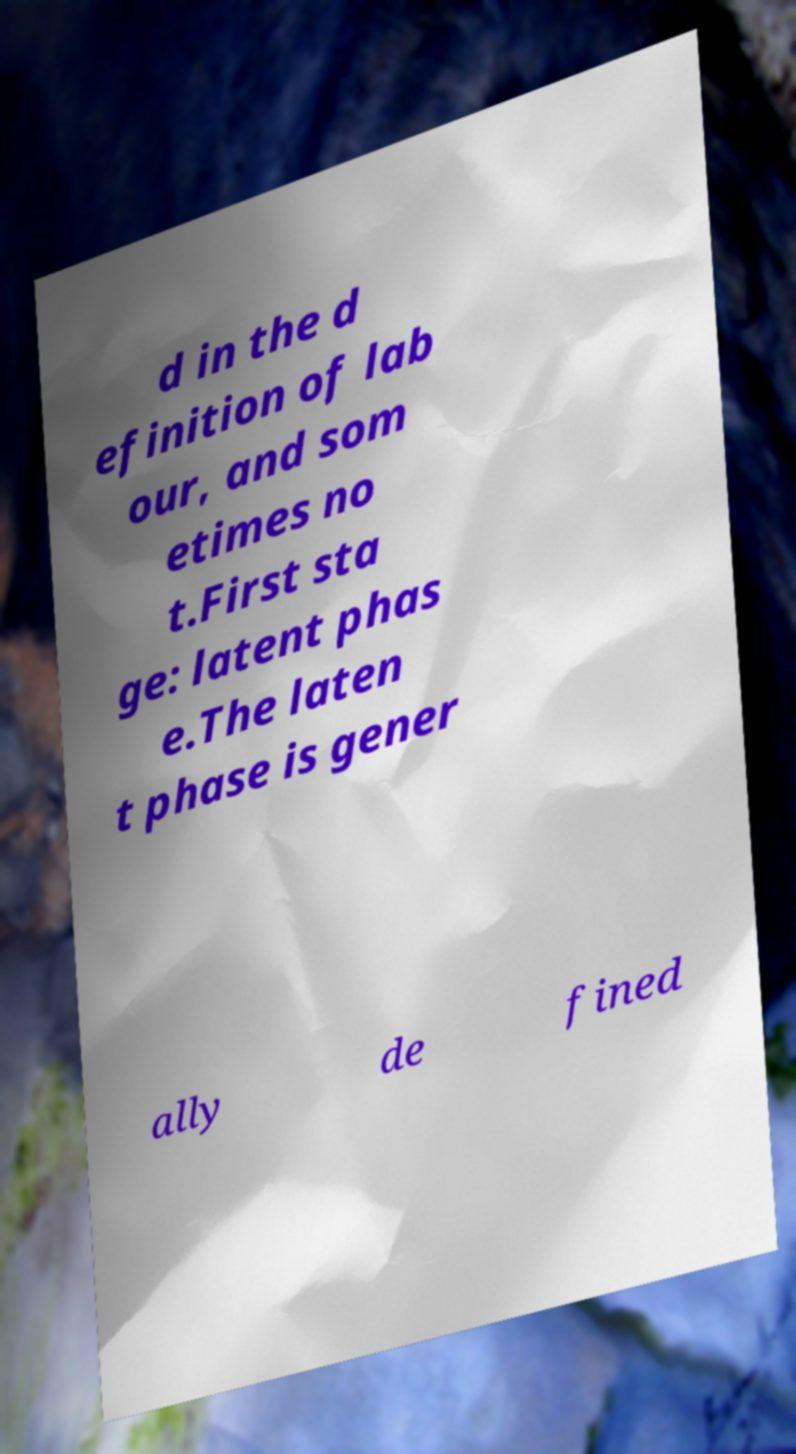Could you extract and type out the text from this image? d in the d efinition of lab our, and som etimes no t.First sta ge: latent phas e.The laten t phase is gener ally de fined 